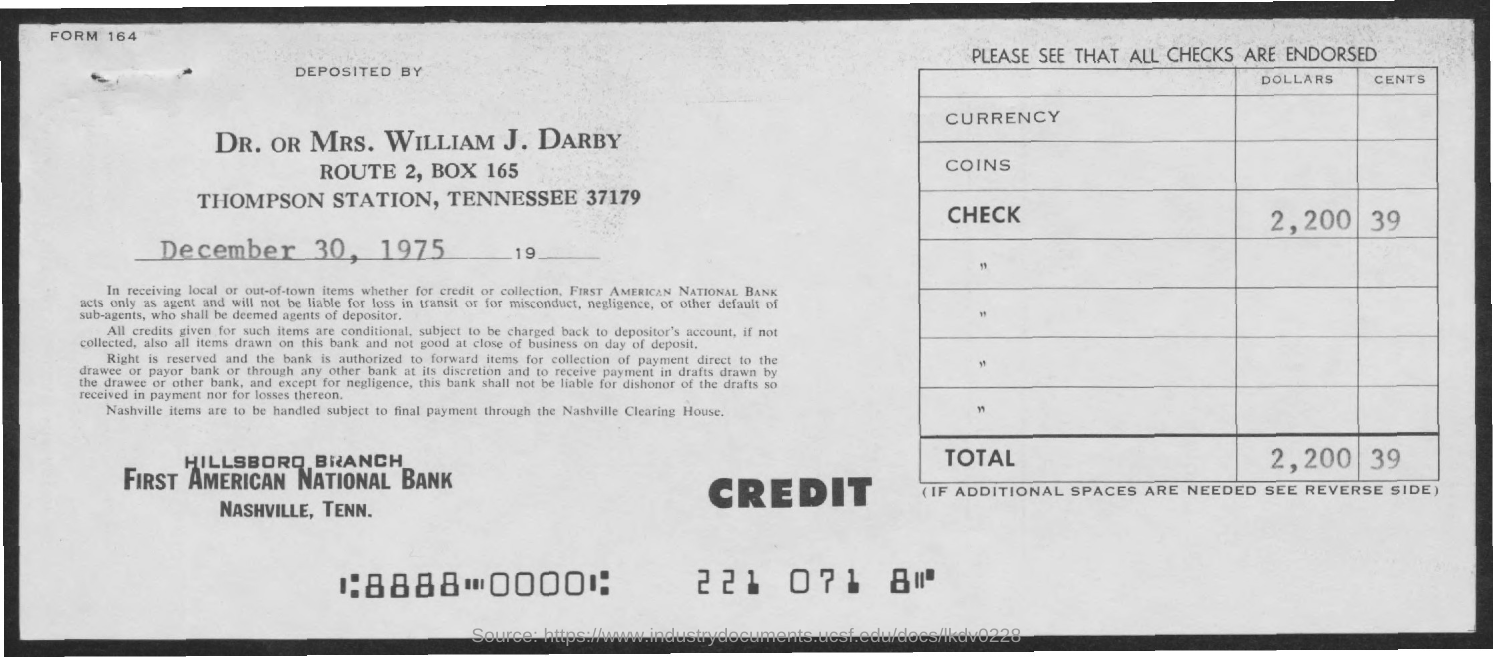What is the date on the document?
Give a very brief answer. December 30, 1975. What is the Check amount?
Provide a succinct answer. 2,200 39. Deposited by whom?
Keep it short and to the point. Dr. or Mrs. William J. Darby. What is the Total?
Provide a short and direct response. 2,200 39. 